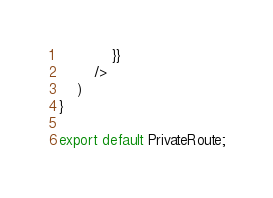Convert code to text. <code><loc_0><loc_0><loc_500><loc_500><_JavaScript_>            }}
        />
    )
}

export default PrivateRoute;</code> 